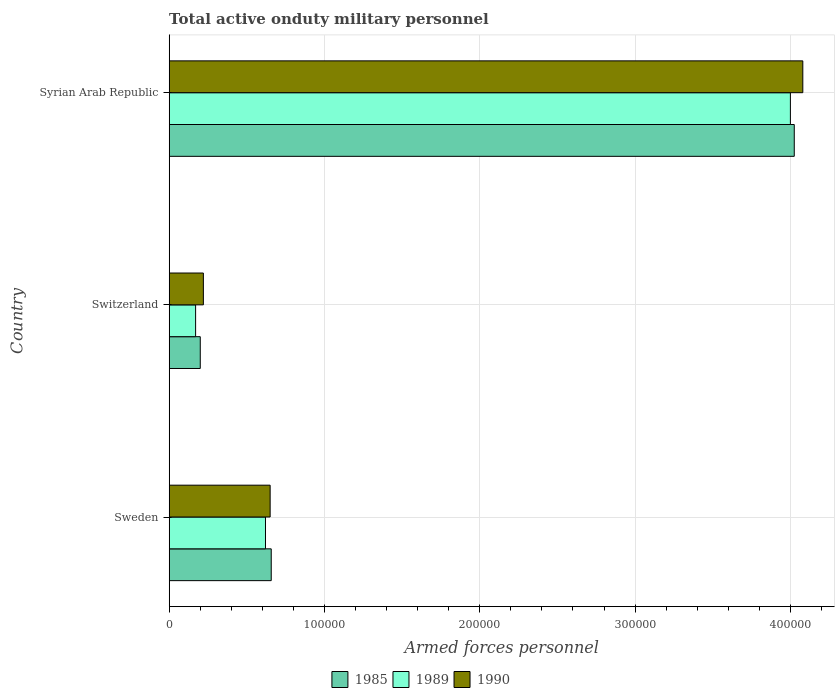How many groups of bars are there?
Ensure brevity in your answer.  3. Are the number of bars per tick equal to the number of legend labels?
Give a very brief answer. Yes. Are the number of bars on each tick of the Y-axis equal?
Offer a terse response. Yes. How many bars are there on the 3rd tick from the bottom?
Ensure brevity in your answer.  3. What is the label of the 2nd group of bars from the top?
Offer a very short reply. Switzerland. What is the number of armed forces personnel in 1989 in Syrian Arab Republic?
Offer a very short reply. 4.00e+05. Across all countries, what is the maximum number of armed forces personnel in 1989?
Your answer should be compact. 4.00e+05. Across all countries, what is the minimum number of armed forces personnel in 1990?
Make the answer very short. 2.20e+04. In which country was the number of armed forces personnel in 1989 maximum?
Give a very brief answer. Syrian Arab Republic. In which country was the number of armed forces personnel in 1989 minimum?
Your answer should be very brief. Switzerland. What is the total number of armed forces personnel in 1990 in the graph?
Your answer should be very brief. 4.95e+05. What is the difference between the number of armed forces personnel in 1989 in Sweden and that in Syrian Arab Republic?
Provide a short and direct response. -3.38e+05. What is the difference between the number of armed forces personnel in 1985 in Syrian Arab Republic and the number of armed forces personnel in 1990 in Sweden?
Your answer should be compact. 3.38e+05. What is the average number of armed forces personnel in 1989 per country?
Give a very brief answer. 1.60e+05. What is the difference between the number of armed forces personnel in 1985 and number of armed forces personnel in 1989 in Switzerland?
Your answer should be compact. 3000. In how many countries, is the number of armed forces personnel in 1989 greater than 80000 ?
Your response must be concise. 1. What is the ratio of the number of armed forces personnel in 1989 in Sweden to that in Switzerland?
Your answer should be very brief. 3.65. Is the number of armed forces personnel in 1985 in Sweden less than that in Syrian Arab Republic?
Provide a succinct answer. Yes. What is the difference between the highest and the second highest number of armed forces personnel in 1990?
Provide a short and direct response. 3.43e+05. What is the difference between the highest and the lowest number of armed forces personnel in 1990?
Offer a very short reply. 3.86e+05. Is the sum of the number of armed forces personnel in 1985 in Switzerland and Syrian Arab Republic greater than the maximum number of armed forces personnel in 1989 across all countries?
Your answer should be very brief. Yes. What does the 2nd bar from the top in Syrian Arab Republic represents?
Make the answer very short. 1989. Is it the case that in every country, the sum of the number of armed forces personnel in 1990 and number of armed forces personnel in 1985 is greater than the number of armed forces personnel in 1989?
Ensure brevity in your answer.  Yes. How many bars are there?
Your answer should be very brief. 9. Are all the bars in the graph horizontal?
Offer a terse response. Yes. How many countries are there in the graph?
Provide a short and direct response. 3. What is the difference between two consecutive major ticks on the X-axis?
Your answer should be compact. 1.00e+05. Are the values on the major ticks of X-axis written in scientific E-notation?
Provide a succinct answer. No. How are the legend labels stacked?
Provide a short and direct response. Horizontal. What is the title of the graph?
Your response must be concise. Total active onduty military personnel. Does "1965" appear as one of the legend labels in the graph?
Your response must be concise. No. What is the label or title of the X-axis?
Provide a short and direct response. Armed forces personnel. What is the label or title of the Y-axis?
Ensure brevity in your answer.  Country. What is the Armed forces personnel of 1985 in Sweden?
Ensure brevity in your answer.  6.57e+04. What is the Armed forces personnel in 1989 in Sweden?
Offer a very short reply. 6.20e+04. What is the Armed forces personnel of 1990 in Sweden?
Ensure brevity in your answer.  6.50e+04. What is the Armed forces personnel of 1989 in Switzerland?
Your answer should be very brief. 1.70e+04. What is the Armed forces personnel in 1990 in Switzerland?
Offer a very short reply. 2.20e+04. What is the Armed forces personnel of 1985 in Syrian Arab Republic?
Your response must be concise. 4.02e+05. What is the Armed forces personnel in 1989 in Syrian Arab Republic?
Your answer should be compact. 4.00e+05. What is the Armed forces personnel of 1990 in Syrian Arab Republic?
Make the answer very short. 4.08e+05. Across all countries, what is the maximum Armed forces personnel of 1985?
Provide a succinct answer. 4.02e+05. Across all countries, what is the maximum Armed forces personnel of 1990?
Provide a succinct answer. 4.08e+05. Across all countries, what is the minimum Armed forces personnel in 1985?
Give a very brief answer. 2.00e+04. Across all countries, what is the minimum Armed forces personnel of 1989?
Your answer should be compact. 1.70e+04. Across all countries, what is the minimum Armed forces personnel in 1990?
Provide a succinct answer. 2.20e+04. What is the total Armed forces personnel of 1985 in the graph?
Your answer should be compact. 4.88e+05. What is the total Armed forces personnel in 1989 in the graph?
Provide a short and direct response. 4.79e+05. What is the total Armed forces personnel of 1990 in the graph?
Keep it short and to the point. 4.95e+05. What is the difference between the Armed forces personnel of 1985 in Sweden and that in Switzerland?
Your answer should be very brief. 4.57e+04. What is the difference between the Armed forces personnel in 1989 in Sweden and that in Switzerland?
Give a very brief answer. 4.50e+04. What is the difference between the Armed forces personnel in 1990 in Sweden and that in Switzerland?
Make the answer very short. 4.30e+04. What is the difference between the Armed forces personnel of 1985 in Sweden and that in Syrian Arab Republic?
Provide a short and direct response. -3.37e+05. What is the difference between the Armed forces personnel in 1989 in Sweden and that in Syrian Arab Republic?
Provide a short and direct response. -3.38e+05. What is the difference between the Armed forces personnel of 1990 in Sweden and that in Syrian Arab Republic?
Your response must be concise. -3.43e+05. What is the difference between the Armed forces personnel of 1985 in Switzerland and that in Syrian Arab Republic?
Offer a very short reply. -3.82e+05. What is the difference between the Armed forces personnel in 1989 in Switzerland and that in Syrian Arab Republic?
Your answer should be very brief. -3.83e+05. What is the difference between the Armed forces personnel in 1990 in Switzerland and that in Syrian Arab Republic?
Give a very brief answer. -3.86e+05. What is the difference between the Armed forces personnel in 1985 in Sweden and the Armed forces personnel in 1989 in Switzerland?
Provide a short and direct response. 4.87e+04. What is the difference between the Armed forces personnel of 1985 in Sweden and the Armed forces personnel of 1990 in Switzerland?
Ensure brevity in your answer.  4.37e+04. What is the difference between the Armed forces personnel in 1985 in Sweden and the Armed forces personnel in 1989 in Syrian Arab Republic?
Your response must be concise. -3.34e+05. What is the difference between the Armed forces personnel in 1985 in Sweden and the Armed forces personnel in 1990 in Syrian Arab Republic?
Your response must be concise. -3.42e+05. What is the difference between the Armed forces personnel in 1989 in Sweden and the Armed forces personnel in 1990 in Syrian Arab Republic?
Give a very brief answer. -3.46e+05. What is the difference between the Armed forces personnel of 1985 in Switzerland and the Armed forces personnel of 1989 in Syrian Arab Republic?
Give a very brief answer. -3.80e+05. What is the difference between the Armed forces personnel of 1985 in Switzerland and the Armed forces personnel of 1990 in Syrian Arab Republic?
Your response must be concise. -3.88e+05. What is the difference between the Armed forces personnel of 1989 in Switzerland and the Armed forces personnel of 1990 in Syrian Arab Republic?
Provide a short and direct response. -3.91e+05. What is the average Armed forces personnel in 1985 per country?
Provide a succinct answer. 1.63e+05. What is the average Armed forces personnel in 1989 per country?
Ensure brevity in your answer.  1.60e+05. What is the average Armed forces personnel of 1990 per country?
Your response must be concise. 1.65e+05. What is the difference between the Armed forces personnel in 1985 and Armed forces personnel in 1989 in Sweden?
Offer a very short reply. 3700. What is the difference between the Armed forces personnel of 1985 and Armed forces personnel of 1990 in Sweden?
Give a very brief answer. 700. What is the difference between the Armed forces personnel in 1989 and Armed forces personnel in 1990 in Sweden?
Make the answer very short. -3000. What is the difference between the Armed forces personnel of 1985 and Armed forces personnel of 1989 in Switzerland?
Provide a succinct answer. 3000. What is the difference between the Armed forces personnel in 1985 and Armed forces personnel in 1990 in Switzerland?
Offer a very short reply. -2000. What is the difference between the Armed forces personnel of 1989 and Armed forces personnel of 1990 in Switzerland?
Your answer should be very brief. -5000. What is the difference between the Armed forces personnel in 1985 and Armed forces personnel in 1989 in Syrian Arab Republic?
Ensure brevity in your answer.  2500. What is the difference between the Armed forces personnel in 1985 and Armed forces personnel in 1990 in Syrian Arab Republic?
Your answer should be very brief. -5500. What is the difference between the Armed forces personnel of 1989 and Armed forces personnel of 1990 in Syrian Arab Republic?
Ensure brevity in your answer.  -8000. What is the ratio of the Armed forces personnel of 1985 in Sweden to that in Switzerland?
Offer a very short reply. 3.29. What is the ratio of the Armed forces personnel of 1989 in Sweden to that in Switzerland?
Offer a terse response. 3.65. What is the ratio of the Armed forces personnel in 1990 in Sweden to that in Switzerland?
Give a very brief answer. 2.95. What is the ratio of the Armed forces personnel in 1985 in Sweden to that in Syrian Arab Republic?
Your response must be concise. 0.16. What is the ratio of the Armed forces personnel in 1989 in Sweden to that in Syrian Arab Republic?
Provide a short and direct response. 0.15. What is the ratio of the Armed forces personnel of 1990 in Sweden to that in Syrian Arab Republic?
Your answer should be very brief. 0.16. What is the ratio of the Armed forces personnel of 1985 in Switzerland to that in Syrian Arab Republic?
Offer a very short reply. 0.05. What is the ratio of the Armed forces personnel in 1989 in Switzerland to that in Syrian Arab Republic?
Offer a very short reply. 0.04. What is the ratio of the Armed forces personnel of 1990 in Switzerland to that in Syrian Arab Republic?
Make the answer very short. 0.05. What is the difference between the highest and the second highest Armed forces personnel of 1985?
Give a very brief answer. 3.37e+05. What is the difference between the highest and the second highest Armed forces personnel in 1989?
Offer a very short reply. 3.38e+05. What is the difference between the highest and the second highest Armed forces personnel of 1990?
Your answer should be very brief. 3.43e+05. What is the difference between the highest and the lowest Armed forces personnel of 1985?
Your answer should be very brief. 3.82e+05. What is the difference between the highest and the lowest Armed forces personnel of 1989?
Your answer should be compact. 3.83e+05. What is the difference between the highest and the lowest Armed forces personnel of 1990?
Give a very brief answer. 3.86e+05. 